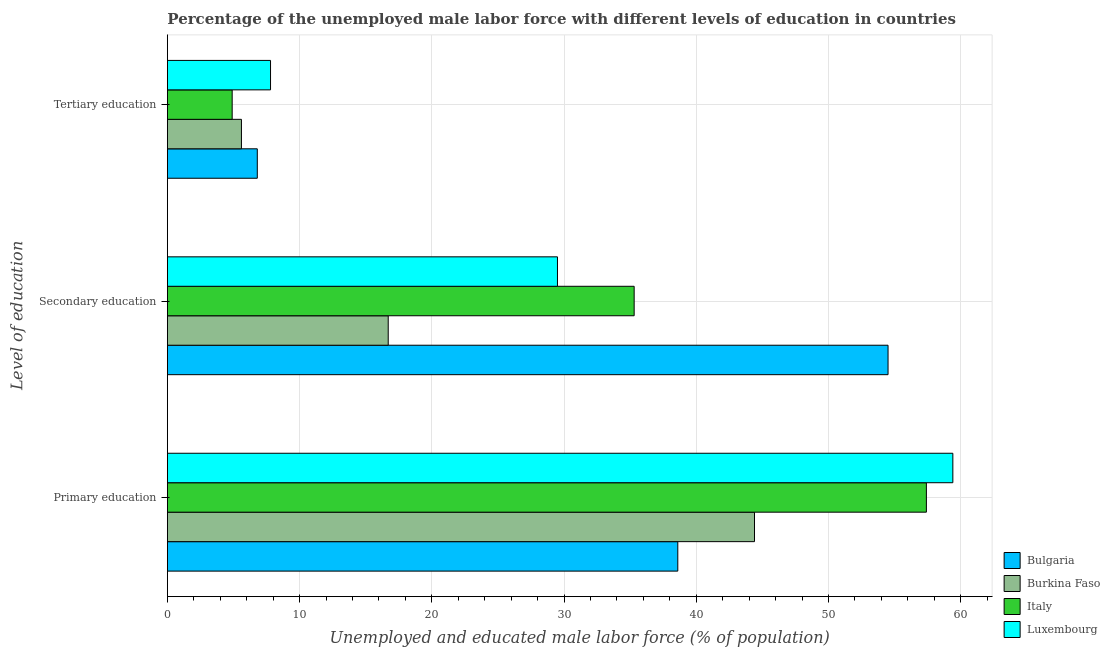How many different coloured bars are there?
Make the answer very short. 4. How many groups of bars are there?
Provide a succinct answer. 3. Are the number of bars on each tick of the Y-axis equal?
Provide a short and direct response. Yes. How many bars are there on the 2nd tick from the top?
Your answer should be compact. 4. What is the label of the 1st group of bars from the top?
Provide a succinct answer. Tertiary education. What is the percentage of male labor force who received primary education in Bulgaria?
Give a very brief answer. 38.6. Across all countries, what is the maximum percentage of male labor force who received secondary education?
Your answer should be compact. 54.5. Across all countries, what is the minimum percentage of male labor force who received primary education?
Ensure brevity in your answer.  38.6. In which country was the percentage of male labor force who received secondary education maximum?
Offer a terse response. Bulgaria. In which country was the percentage of male labor force who received tertiary education minimum?
Provide a succinct answer. Italy. What is the total percentage of male labor force who received tertiary education in the graph?
Provide a short and direct response. 25.1. What is the difference between the percentage of male labor force who received tertiary education in Luxembourg and that in Italy?
Provide a succinct answer. 2.9. What is the difference between the percentage of male labor force who received secondary education in Luxembourg and the percentage of male labor force who received tertiary education in Italy?
Provide a succinct answer. 24.6. What is the average percentage of male labor force who received tertiary education per country?
Provide a succinct answer. 6.28. What is the difference between the percentage of male labor force who received primary education and percentage of male labor force who received tertiary education in Italy?
Make the answer very short. 52.5. In how many countries, is the percentage of male labor force who received secondary education greater than 32 %?
Provide a short and direct response. 2. What is the ratio of the percentage of male labor force who received tertiary education in Italy to that in Bulgaria?
Ensure brevity in your answer.  0.72. What is the difference between the highest and the second highest percentage of male labor force who received primary education?
Make the answer very short. 2. What is the difference between the highest and the lowest percentage of male labor force who received tertiary education?
Offer a terse response. 2.9. In how many countries, is the percentage of male labor force who received primary education greater than the average percentage of male labor force who received primary education taken over all countries?
Offer a terse response. 2. What does the 3rd bar from the top in Primary education represents?
Your response must be concise. Burkina Faso. What does the 3rd bar from the bottom in Tertiary education represents?
Offer a terse response. Italy. How many bars are there?
Provide a succinct answer. 12. How many countries are there in the graph?
Your response must be concise. 4. What is the difference between two consecutive major ticks on the X-axis?
Ensure brevity in your answer.  10. Are the values on the major ticks of X-axis written in scientific E-notation?
Give a very brief answer. No. How many legend labels are there?
Keep it short and to the point. 4. What is the title of the graph?
Provide a succinct answer. Percentage of the unemployed male labor force with different levels of education in countries. What is the label or title of the X-axis?
Your response must be concise. Unemployed and educated male labor force (% of population). What is the label or title of the Y-axis?
Offer a very short reply. Level of education. What is the Unemployed and educated male labor force (% of population) in Bulgaria in Primary education?
Your answer should be compact. 38.6. What is the Unemployed and educated male labor force (% of population) in Burkina Faso in Primary education?
Your response must be concise. 44.4. What is the Unemployed and educated male labor force (% of population) of Italy in Primary education?
Give a very brief answer. 57.4. What is the Unemployed and educated male labor force (% of population) of Luxembourg in Primary education?
Make the answer very short. 59.4. What is the Unemployed and educated male labor force (% of population) in Bulgaria in Secondary education?
Your response must be concise. 54.5. What is the Unemployed and educated male labor force (% of population) in Burkina Faso in Secondary education?
Your answer should be compact. 16.7. What is the Unemployed and educated male labor force (% of population) of Italy in Secondary education?
Your response must be concise. 35.3. What is the Unemployed and educated male labor force (% of population) of Luxembourg in Secondary education?
Ensure brevity in your answer.  29.5. What is the Unemployed and educated male labor force (% of population) of Bulgaria in Tertiary education?
Your answer should be very brief. 6.8. What is the Unemployed and educated male labor force (% of population) of Burkina Faso in Tertiary education?
Offer a terse response. 5.6. What is the Unemployed and educated male labor force (% of population) of Italy in Tertiary education?
Provide a short and direct response. 4.9. What is the Unemployed and educated male labor force (% of population) in Luxembourg in Tertiary education?
Make the answer very short. 7.8. Across all Level of education, what is the maximum Unemployed and educated male labor force (% of population) of Bulgaria?
Ensure brevity in your answer.  54.5. Across all Level of education, what is the maximum Unemployed and educated male labor force (% of population) of Burkina Faso?
Offer a very short reply. 44.4. Across all Level of education, what is the maximum Unemployed and educated male labor force (% of population) of Italy?
Keep it short and to the point. 57.4. Across all Level of education, what is the maximum Unemployed and educated male labor force (% of population) of Luxembourg?
Your answer should be very brief. 59.4. Across all Level of education, what is the minimum Unemployed and educated male labor force (% of population) of Bulgaria?
Ensure brevity in your answer.  6.8. Across all Level of education, what is the minimum Unemployed and educated male labor force (% of population) in Burkina Faso?
Offer a very short reply. 5.6. Across all Level of education, what is the minimum Unemployed and educated male labor force (% of population) in Italy?
Your answer should be compact. 4.9. Across all Level of education, what is the minimum Unemployed and educated male labor force (% of population) in Luxembourg?
Your answer should be very brief. 7.8. What is the total Unemployed and educated male labor force (% of population) of Bulgaria in the graph?
Ensure brevity in your answer.  99.9. What is the total Unemployed and educated male labor force (% of population) in Burkina Faso in the graph?
Keep it short and to the point. 66.7. What is the total Unemployed and educated male labor force (% of population) of Italy in the graph?
Offer a very short reply. 97.6. What is the total Unemployed and educated male labor force (% of population) in Luxembourg in the graph?
Your response must be concise. 96.7. What is the difference between the Unemployed and educated male labor force (% of population) in Bulgaria in Primary education and that in Secondary education?
Your answer should be very brief. -15.9. What is the difference between the Unemployed and educated male labor force (% of population) of Burkina Faso in Primary education and that in Secondary education?
Your response must be concise. 27.7. What is the difference between the Unemployed and educated male labor force (% of population) in Italy in Primary education and that in Secondary education?
Ensure brevity in your answer.  22.1. What is the difference between the Unemployed and educated male labor force (% of population) of Luxembourg in Primary education and that in Secondary education?
Offer a terse response. 29.9. What is the difference between the Unemployed and educated male labor force (% of population) in Bulgaria in Primary education and that in Tertiary education?
Offer a terse response. 31.8. What is the difference between the Unemployed and educated male labor force (% of population) in Burkina Faso in Primary education and that in Tertiary education?
Keep it short and to the point. 38.8. What is the difference between the Unemployed and educated male labor force (% of population) of Italy in Primary education and that in Tertiary education?
Your answer should be very brief. 52.5. What is the difference between the Unemployed and educated male labor force (% of population) of Luxembourg in Primary education and that in Tertiary education?
Keep it short and to the point. 51.6. What is the difference between the Unemployed and educated male labor force (% of population) in Bulgaria in Secondary education and that in Tertiary education?
Make the answer very short. 47.7. What is the difference between the Unemployed and educated male labor force (% of population) of Italy in Secondary education and that in Tertiary education?
Provide a short and direct response. 30.4. What is the difference between the Unemployed and educated male labor force (% of population) in Luxembourg in Secondary education and that in Tertiary education?
Give a very brief answer. 21.7. What is the difference between the Unemployed and educated male labor force (% of population) in Bulgaria in Primary education and the Unemployed and educated male labor force (% of population) in Burkina Faso in Secondary education?
Keep it short and to the point. 21.9. What is the difference between the Unemployed and educated male labor force (% of population) in Bulgaria in Primary education and the Unemployed and educated male labor force (% of population) in Italy in Secondary education?
Give a very brief answer. 3.3. What is the difference between the Unemployed and educated male labor force (% of population) in Italy in Primary education and the Unemployed and educated male labor force (% of population) in Luxembourg in Secondary education?
Offer a terse response. 27.9. What is the difference between the Unemployed and educated male labor force (% of population) in Bulgaria in Primary education and the Unemployed and educated male labor force (% of population) in Burkina Faso in Tertiary education?
Your answer should be very brief. 33. What is the difference between the Unemployed and educated male labor force (% of population) in Bulgaria in Primary education and the Unemployed and educated male labor force (% of population) in Italy in Tertiary education?
Keep it short and to the point. 33.7. What is the difference between the Unemployed and educated male labor force (% of population) of Bulgaria in Primary education and the Unemployed and educated male labor force (% of population) of Luxembourg in Tertiary education?
Provide a short and direct response. 30.8. What is the difference between the Unemployed and educated male labor force (% of population) of Burkina Faso in Primary education and the Unemployed and educated male labor force (% of population) of Italy in Tertiary education?
Offer a very short reply. 39.5. What is the difference between the Unemployed and educated male labor force (% of population) in Burkina Faso in Primary education and the Unemployed and educated male labor force (% of population) in Luxembourg in Tertiary education?
Provide a succinct answer. 36.6. What is the difference between the Unemployed and educated male labor force (% of population) of Italy in Primary education and the Unemployed and educated male labor force (% of population) of Luxembourg in Tertiary education?
Give a very brief answer. 49.6. What is the difference between the Unemployed and educated male labor force (% of population) of Bulgaria in Secondary education and the Unemployed and educated male labor force (% of population) of Burkina Faso in Tertiary education?
Give a very brief answer. 48.9. What is the difference between the Unemployed and educated male labor force (% of population) of Bulgaria in Secondary education and the Unemployed and educated male labor force (% of population) of Italy in Tertiary education?
Offer a very short reply. 49.6. What is the difference between the Unemployed and educated male labor force (% of population) of Bulgaria in Secondary education and the Unemployed and educated male labor force (% of population) of Luxembourg in Tertiary education?
Offer a terse response. 46.7. What is the difference between the Unemployed and educated male labor force (% of population) of Burkina Faso in Secondary education and the Unemployed and educated male labor force (% of population) of Luxembourg in Tertiary education?
Provide a short and direct response. 8.9. What is the average Unemployed and educated male labor force (% of population) of Bulgaria per Level of education?
Give a very brief answer. 33.3. What is the average Unemployed and educated male labor force (% of population) in Burkina Faso per Level of education?
Offer a very short reply. 22.23. What is the average Unemployed and educated male labor force (% of population) of Italy per Level of education?
Give a very brief answer. 32.53. What is the average Unemployed and educated male labor force (% of population) in Luxembourg per Level of education?
Make the answer very short. 32.23. What is the difference between the Unemployed and educated male labor force (% of population) of Bulgaria and Unemployed and educated male labor force (% of population) of Italy in Primary education?
Make the answer very short. -18.8. What is the difference between the Unemployed and educated male labor force (% of population) in Bulgaria and Unemployed and educated male labor force (% of population) in Luxembourg in Primary education?
Your answer should be very brief. -20.8. What is the difference between the Unemployed and educated male labor force (% of population) in Burkina Faso and Unemployed and educated male labor force (% of population) in Luxembourg in Primary education?
Your response must be concise. -15. What is the difference between the Unemployed and educated male labor force (% of population) of Italy and Unemployed and educated male labor force (% of population) of Luxembourg in Primary education?
Your response must be concise. -2. What is the difference between the Unemployed and educated male labor force (% of population) of Bulgaria and Unemployed and educated male labor force (% of population) of Burkina Faso in Secondary education?
Your response must be concise. 37.8. What is the difference between the Unemployed and educated male labor force (% of population) in Bulgaria and Unemployed and educated male labor force (% of population) in Luxembourg in Secondary education?
Your answer should be very brief. 25. What is the difference between the Unemployed and educated male labor force (% of population) of Burkina Faso and Unemployed and educated male labor force (% of population) of Italy in Secondary education?
Offer a terse response. -18.6. What is the difference between the Unemployed and educated male labor force (% of population) of Burkina Faso and Unemployed and educated male labor force (% of population) of Luxembourg in Secondary education?
Make the answer very short. -12.8. What is the difference between the Unemployed and educated male labor force (% of population) in Bulgaria and Unemployed and educated male labor force (% of population) in Luxembourg in Tertiary education?
Your response must be concise. -1. What is the difference between the Unemployed and educated male labor force (% of population) of Burkina Faso and Unemployed and educated male labor force (% of population) of Luxembourg in Tertiary education?
Make the answer very short. -2.2. What is the ratio of the Unemployed and educated male labor force (% of population) in Bulgaria in Primary education to that in Secondary education?
Offer a very short reply. 0.71. What is the ratio of the Unemployed and educated male labor force (% of population) of Burkina Faso in Primary education to that in Secondary education?
Ensure brevity in your answer.  2.66. What is the ratio of the Unemployed and educated male labor force (% of population) of Italy in Primary education to that in Secondary education?
Ensure brevity in your answer.  1.63. What is the ratio of the Unemployed and educated male labor force (% of population) of Luxembourg in Primary education to that in Secondary education?
Ensure brevity in your answer.  2.01. What is the ratio of the Unemployed and educated male labor force (% of population) of Bulgaria in Primary education to that in Tertiary education?
Your response must be concise. 5.68. What is the ratio of the Unemployed and educated male labor force (% of population) in Burkina Faso in Primary education to that in Tertiary education?
Make the answer very short. 7.93. What is the ratio of the Unemployed and educated male labor force (% of population) of Italy in Primary education to that in Tertiary education?
Provide a short and direct response. 11.71. What is the ratio of the Unemployed and educated male labor force (% of population) in Luxembourg in Primary education to that in Tertiary education?
Provide a short and direct response. 7.62. What is the ratio of the Unemployed and educated male labor force (% of population) in Bulgaria in Secondary education to that in Tertiary education?
Offer a terse response. 8.01. What is the ratio of the Unemployed and educated male labor force (% of population) in Burkina Faso in Secondary education to that in Tertiary education?
Your response must be concise. 2.98. What is the ratio of the Unemployed and educated male labor force (% of population) in Italy in Secondary education to that in Tertiary education?
Ensure brevity in your answer.  7.2. What is the ratio of the Unemployed and educated male labor force (% of population) in Luxembourg in Secondary education to that in Tertiary education?
Provide a succinct answer. 3.78. What is the difference between the highest and the second highest Unemployed and educated male labor force (% of population) of Burkina Faso?
Ensure brevity in your answer.  27.7. What is the difference between the highest and the second highest Unemployed and educated male labor force (% of population) in Italy?
Your response must be concise. 22.1. What is the difference between the highest and the second highest Unemployed and educated male labor force (% of population) of Luxembourg?
Provide a short and direct response. 29.9. What is the difference between the highest and the lowest Unemployed and educated male labor force (% of population) of Bulgaria?
Your answer should be compact. 47.7. What is the difference between the highest and the lowest Unemployed and educated male labor force (% of population) of Burkina Faso?
Keep it short and to the point. 38.8. What is the difference between the highest and the lowest Unemployed and educated male labor force (% of population) of Italy?
Provide a short and direct response. 52.5. What is the difference between the highest and the lowest Unemployed and educated male labor force (% of population) in Luxembourg?
Keep it short and to the point. 51.6. 